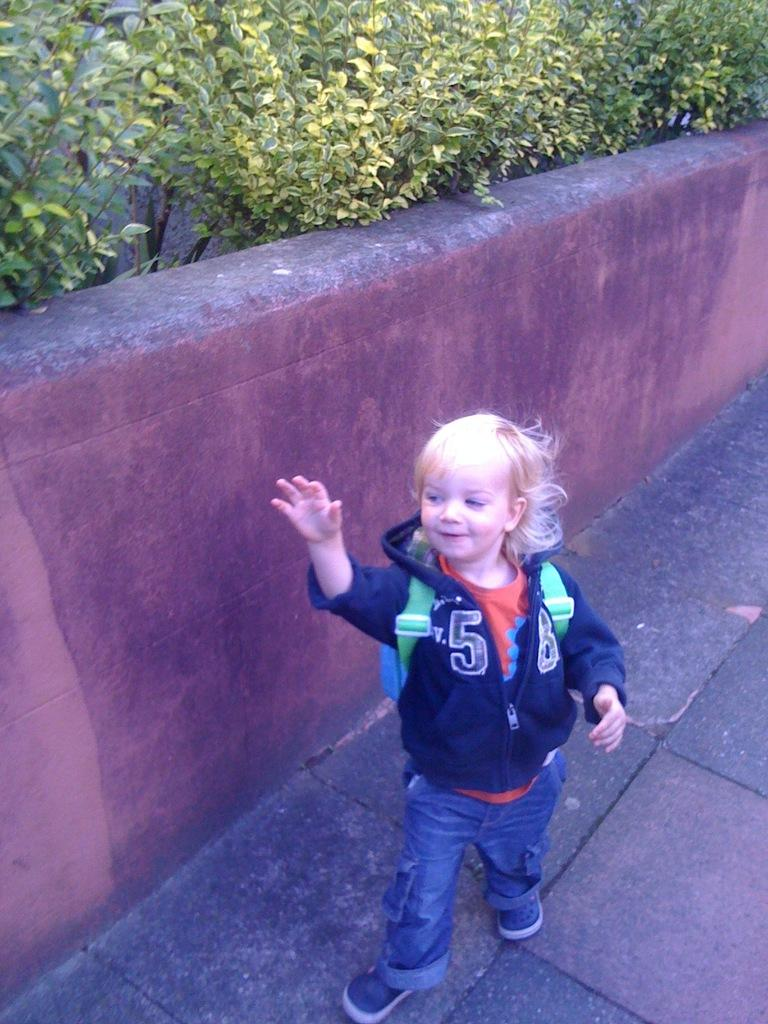<image>
Render a clear and concise summary of the photo. A small child with the number 8 on the jacket 